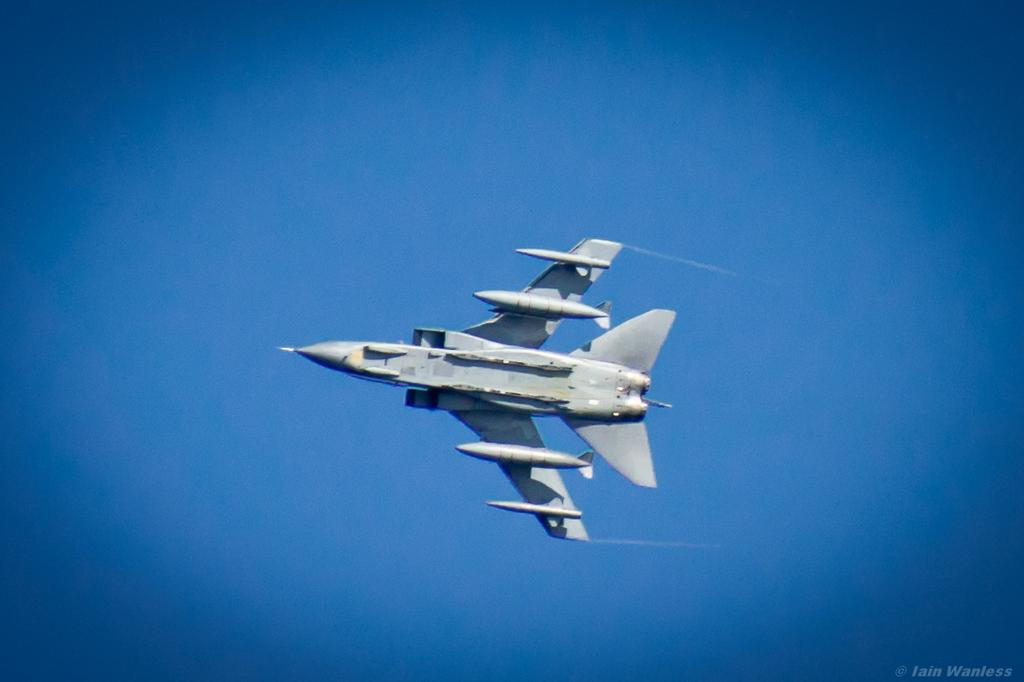What is the main subject of the image? The main subject of the image is an aircraft. What is the aircraft doing in the image? The aircraft is flying in the sky. What type of light can be seen emanating from the clover in the image? There is no clover present in the image, and therefore no such light can be observed. How many yams are visible in the image? There are no yams present in the image. 